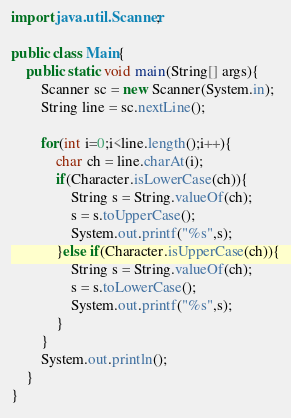Convert code to text. <code><loc_0><loc_0><loc_500><loc_500><_Java_>import java.util.Scanner;

public class Main{
    public static void main(String[] args){
        Scanner sc = new Scanner(System.in);
        String line = sc.nextLine();
        
        for(int i=0;i<line.length();i++){
            char ch = line.charAt(i);
            if(Character.isLowerCase(ch)){
                String s = String.valueOf(ch);
                s = s.toUpperCase();
                System.out.printf("%s",s);
            }else if(Character.isUpperCase(ch)){
                String s = String.valueOf(ch);
                s = s.toLowerCase();
                System.out.printf("%s",s);
            }
        }
        System.out.println();
    }
}
</code> 